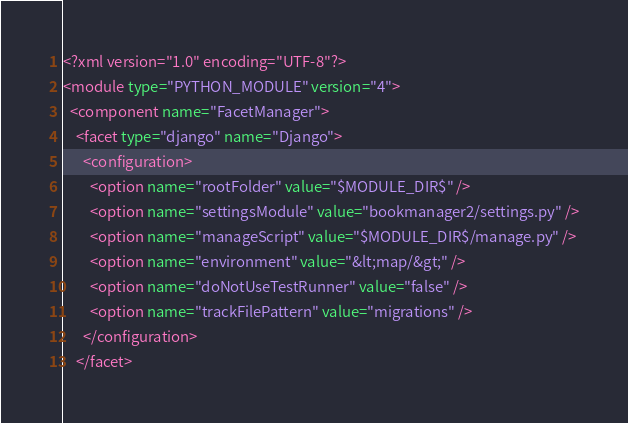<code> <loc_0><loc_0><loc_500><loc_500><_XML_><?xml version="1.0" encoding="UTF-8"?>
<module type="PYTHON_MODULE" version="4">
  <component name="FacetManager">
    <facet type="django" name="Django">
      <configuration>
        <option name="rootFolder" value="$MODULE_DIR$" />
        <option name="settingsModule" value="bookmanager2/settings.py" />
        <option name="manageScript" value="$MODULE_DIR$/manage.py" />
        <option name="environment" value="&lt;map/&gt;" />
        <option name="doNotUseTestRunner" value="false" />
        <option name="trackFilePattern" value="migrations" />
      </configuration>
    </facet></code> 